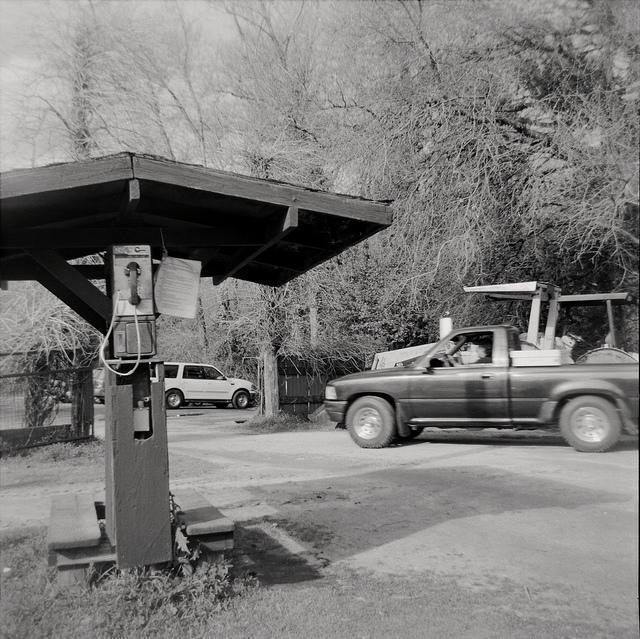The item under the roof can best be described as what?
Pick the correct solution from the four options below to address the question.
Options: Cutting edge, outdated, underwater, bovine. Outdated. 